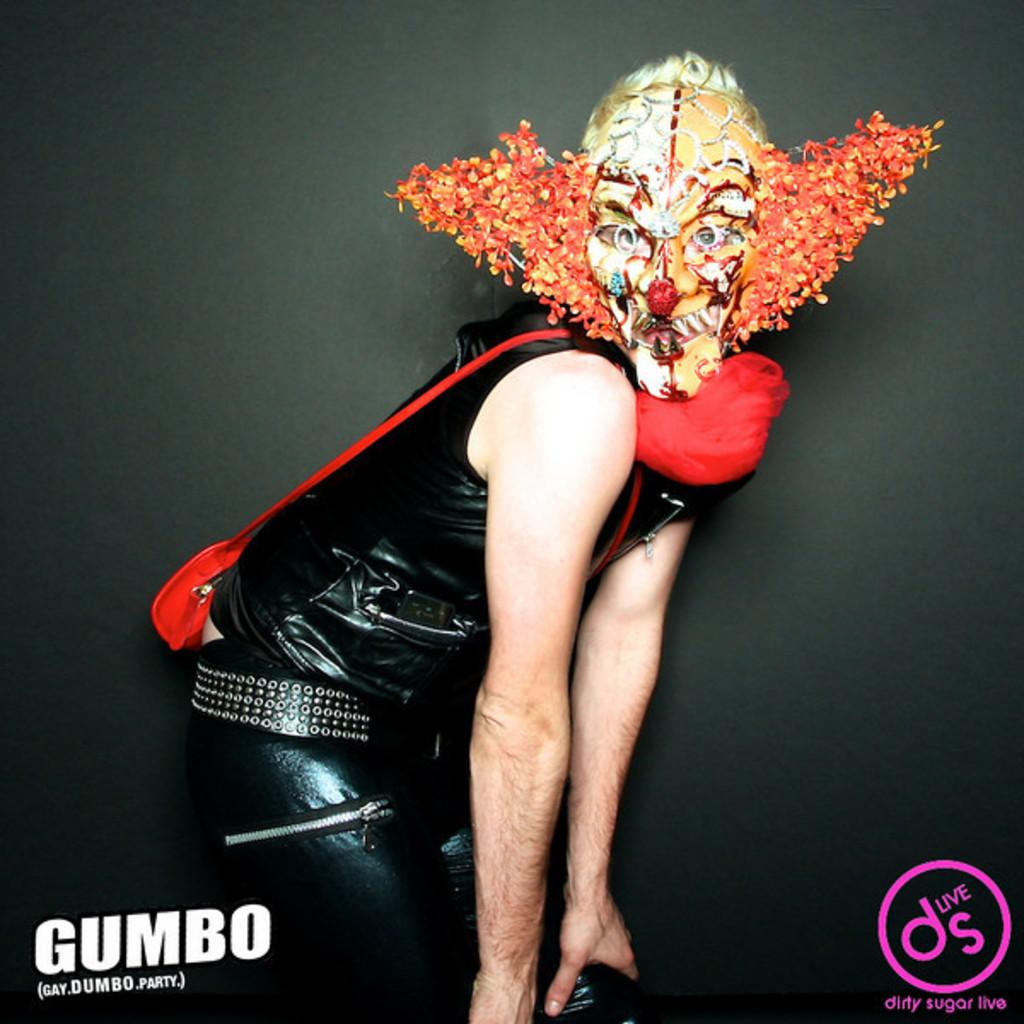Who or what is present in the image? There is a person in the image. What is the person wearing on their face? The person is wearing a mask. What color is the dress the person is wearing? The person is wearing a black dress. What type of bag is the person carrying? The person is wearing a red sling bag. What type of zebra can be seen in the image? There is no zebra present in the image. What is the purpose of the dirt in the image? There is no dirt present in the image. 